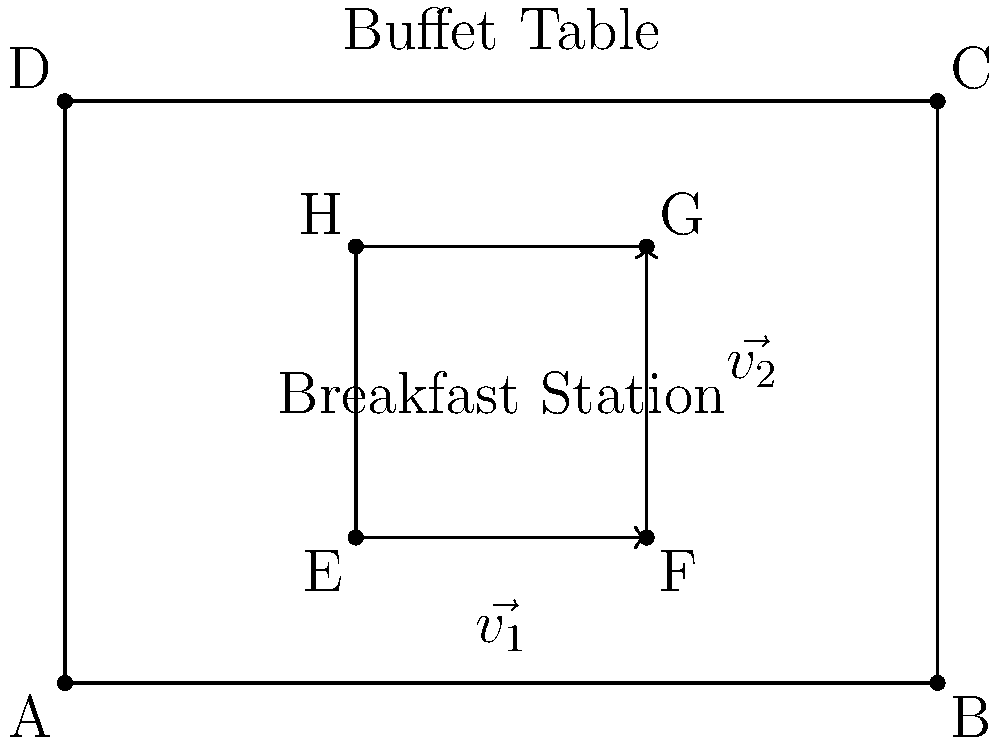As a breakfast blogger, you're helping optimize the layout of a buffet table. The rectangular breakfast station (EFGH) needs to be positioned on the larger buffet table (ABCD). Given that $\vec{v_1} = \overrightarrow{EF}$ and $\vec{v_2} = \overrightarrow{FG}$, what vector operation would you use to find the area of the breakfast station, and how would this help in optimizing the arrangement? To find the area of the breakfast station and optimize its arrangement, we can use the cross product of vectors. Here's a step-by-step explanation:

1. Identify the vectors: We have $\vec{v_1} = \overrightarrow{EF}$ and $\vec{v_2} = \overrightarrow{FG}$.

2. The cross product of two vectors gives us the area of the parallelogram formed by these vectors. In this case, it's the area of the rectangle EFGH.

3. The formula for the cross product magnitude is:
   $$|\vec{v_1} \times \vec{v_2}| = |\vec{v_1}||\vec{v_2}|\sin\theta$$
   where $\theta$ is the angle between the vectors.

4. Since the vectors are perpendicular in a rectangle, $\sin\theta = 1$, simplifying our calculation.

5. The magnitude of the cross product directly gives us the area of the breakfast station:
   $$\text{Area} = |\vec{v_1} \times \vec{v_2}| = |\vec{v_1}||\vec{v_2}|$$

6. Knowing the area helps in optimizing the arrangement by:
   a) Ensuring the breakfast station fits within the larger buffet table.
   b) Maximizing space efficiency by comparing the station's area to the total table area.
   c) Allowing for easy calculation of remaining space for other items or circulation.

7. We can also use the cross product to determine the orientation of the breakfast station relative to the buffet table, which is crucial for traffic flow and accessibility.

By using vector operations, we can quickly calculate areas, optimize space usage, and ensure an efficient layout for the breakfast buffet.
Answer: Cross product of $\vec{v_1}$ and $\vec{v_2}$ 